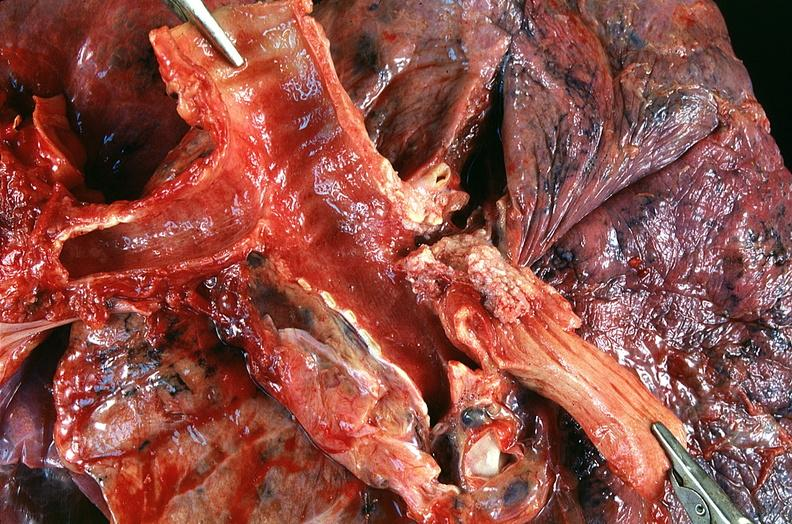does this image show lung, squamous cell carcinoma fungating lesion right mainstbronchus?
Answer the question using a single word or phrase. Yes 